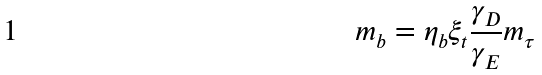Convert formula to latex. <formula><loc_0><loc_0><loc_500><loc_500>m _ { b } = \eta _ { b } \xi _ { t } \frac { \gamma _ { D } } { \gamma _ { E } } m _ { \tau }</formula> 